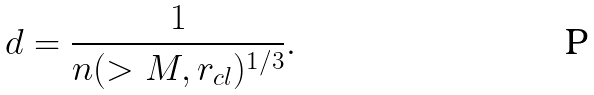Convert formula to latex. <formula><loc_0><loc_0><loc_500><loc_500>d = \frac { 1 } { n ( > M , r _ { c l } ) ^ { 1 / 3 } } .</formula> 